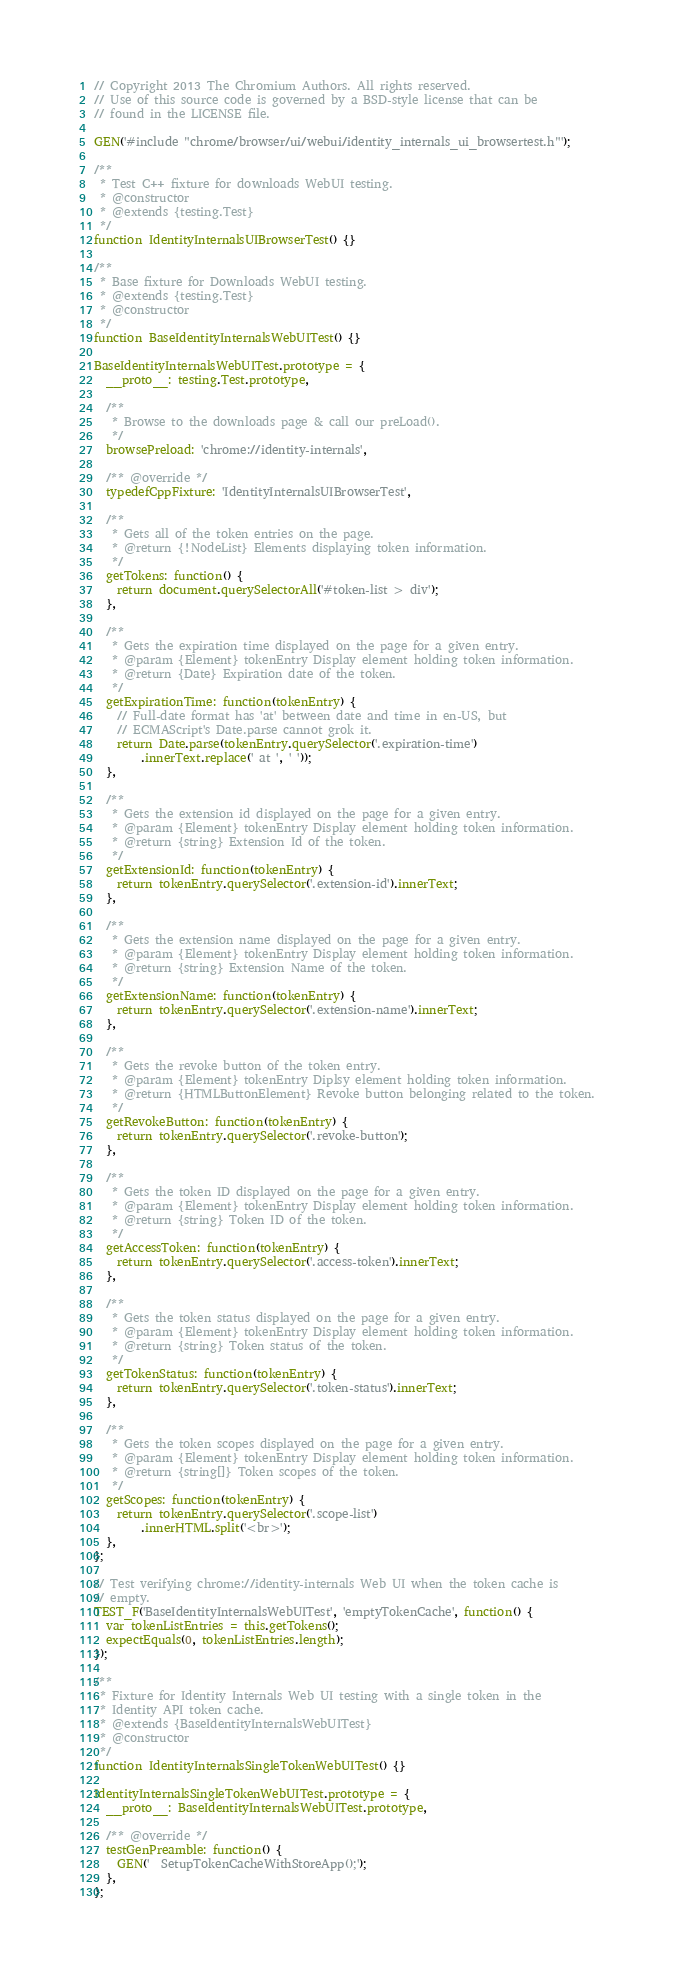<code> <loc_0><loc_0><loc_500><loc_500><_JavaScript_>// Copyright 2013 The Chromium Authors. All rights reserved.
// Use of this source code is governed by a BSD-style license that can be
// found in the LICENSE file.

GEN('#include "chrome/browser/ui/webui/identity_internals_ui_browsertest.h"');

/**
 * Test C++ fixture for downloads WebUI testing.
 * @constructor
 * @extends {testing.Test}
 */
function IdentityInternalsUIBrowserTest() {}

/**
 * Base fixture for Downloads WebUI testing.
 * @extends {testing.Test}
 * @constructor
 */
function BaseIdentityInternalsWebUITest() {}

BaseIdentityInternalsWebUITest.prototype = {
  __proto__: testing.Test.prototype,

  /**
   * Browse to the downloads page & call our preLoad().
   */
  browsePreload: 'chrome://identity-internals',

  /** @override */
  typedefCppFixture: 'IdentityInternalsUIBrowserTest',

  /**
   * Gets all of the token entries on the page.
   * @return {!NodeList} Elements displaying token information.
   */
  getTokens: function() {
    return document.querySelectorAll('#token-list > div');
  },

  /**
   * Gets the expiration time displayed on the page for a given entry.
   * @param {Element} tokenEntry Display element holding token information.
   * @return {Date} Expiration date of the token.
   */
  getExpirationTime: function(tokenEntry) {
    // Full-date format has 'at' between date and time in en-US, but
    // ECMAScript's Date.parse cannot grok it.
    return Date.parse(tokenEntry.querySelector('.expiration-time')
        .innerText.replace(' at ', ' '));
  },

  /**
   * Gets the extension id displayed on the page for a given entry.
   * @param {Element} tokenEntry Display element holding token information.
   * @return {string} Extension Id of the token.
   */
  getExtensionId: function(tokenEntry) {
    return tokenEntry.querySelector('.extension-id').innerText;
  },

  /**
   * Gets the extension name displayed on the page for a given entry.
   * @param {Element} tokenEntry Display element holding token information.
   * @return {string} Extension Name of the token.
   */
  getExtensionName: function(tokenEntry) {
    return tokenEntry.querySelector('.extension-name').innerText;
  },

  /**
   * Gets the revoke button of the token entry.
   * @param {Element} tokenEntry Diplsy element holding token information.
   * @return {HTMLButtonElement} Revoke button belonging related to the token.
   */
  getRevokeButton: function(tokenEntry) {
    return tokenEntry.querySelector('.revoke-button');
  },

  /**
   * Gets the token ID displayed on the page for a given entry.
   * @param {Element} tokenEntry Display element holding token information.
   * @return {string} Token ID of the token.
   */
  getAccessToken: function(tokenEntry) {
    return tokenEntry.querySelector('.access-token').innerText;
  },

  /**
   * Gets the token status displayed on the page for a given entry.
   * @param {Element} tokenEntry Display element holding token information.
   * @return {string} Token status of the token.
   */
  getTokenStatus: function(tokenEntry) {
    return tokenEntry.querySelector('.token-status').innerText;
  },

  /**
   * Gets the token scopes displayed on the page for a given entry.
   * @param {Element} tokenEntry Display element holding token information.
   * @return {string[]} Token scopes of the token.
   */
  getScopes: function(tokenEntry) {
    return tokenEntry.querySelector('.scope-list')
        .innerHTML.split('<br>');
  },
};

// Test verifying chrome://identity-internals Web UI when the token cache is
// empty.
TEST_F('BaseIdentityInternalsWebUITest', 'emptyTokenCache', function() {
  var tokenListEntries = this.getTokens();
  expectEquals(0, tokenListEntries.length);
});

/**
 * Fixture for Identity Internals Web UI testing with a single token in the
 * Identity API token cache.
 * @extends {BaseIdentityInternalsWebUITest}
 * @constructor
 */
function IdentityInternalsSingleTokenWebUITest() {}

IdentityInternalsSingleTokenWebUITest.prototype = {
  __proto__: BaseIdentityInternalsWebUITest.prototype,

  /** @override */
  testGenPreamble: function() {
    GEN('  SetupTokenCacheWithStoreApp();');
  },
};
</code> 